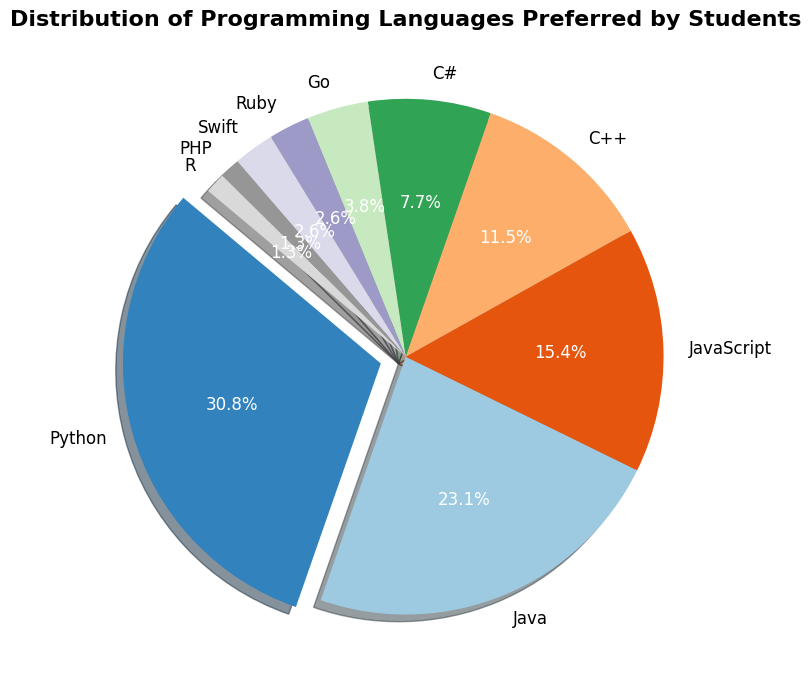What's the most preferred programming language among students? The pie chart shows that the largest section represents Python, which has been highlighted slightly using an "explode" effect. Thus, Python is the most preferred language.
Answer: Python Which programming language has the smallest preference among students? The pie chart shows that the smallest sections represent PHP and R, both with the same percentage. Therefore, both have the smallest preference among students.
Answer: PHP and R How does the preference for JavaScript compare to Java? The pie chart shows that JavaScript has a smaller section compared to Java's section. Thus, fewer students prefer JavaScript compared to Java.
Answer: Fewer What is the sum of preferences for Go, Ruby, Swift, PHP, and R combined? From the pie chart, we see the counts for Go (15), Ruby (10), Swift (10), PHP (5), and R (5). Adding these together: 15 + 10 + 10 + 5 + 5 = 45.
Answer: 45 Which two programming languages have the same preference and what is that preference? Upon examining the pie chart, Ruby and Swift have the same size sections indicating equal preferences. Both are preferred by 10 students each.
Answer: Ruby and Swift, 10 What percentage of students prefer Python? The pie chart provides the percentage values for each section. The section for Python shows 31.7%, indicating that 31.7% of students prefer Python.
Answer: 31.7% Is the preference for C++ greater or lesser than JavaScript? The pie chart sections for C++ and JavaScript show that JavaScript is larger than C++, indicating that the preference for JavaScript is greater than for C++.
Answer: Lesser Combine the preferences for Python, Java, and JavaScript. What is the combined count? From the pie chart, Python (120), Java (90), and JavaScript (60) are summed: 120 + 90 + 60 = 270.
Answer: 270 What is the difference in preference between C# and Swift? The pie chart shows counts for C# (30) and Swift (10). The difference is calculated as 30 - 10 = 20.
Answer: 20 Which programming languages have a preference count less than 20? The pie chart displays smaller sections for the following languages with fewer than 20 students: Go (15), Ruby (10), Swift (10), PHP (5), and R (5).
Answer: Go, Ruby, Swift, PHP, and R 